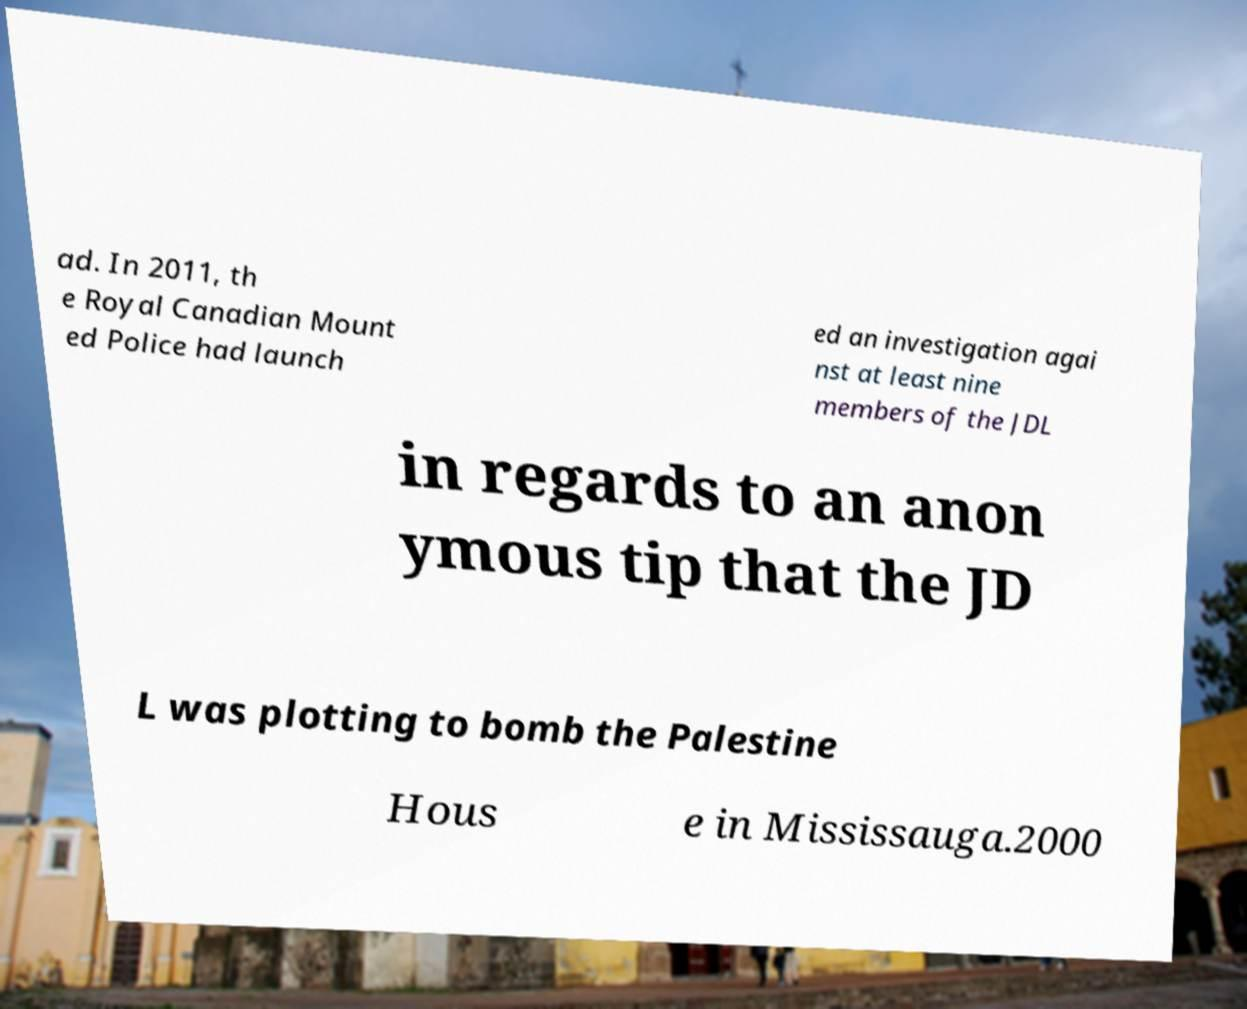I need the written content from this picture converted into text. Can you do that? ad. In 2011, th e Royal Canadian Mount ed Police had launch ed an investigation agai nst at least nine members of the JDL in regards to an anon ymous tip that the JD L was plotting to bomb the Palestine Hous e in Mississauga.2000 